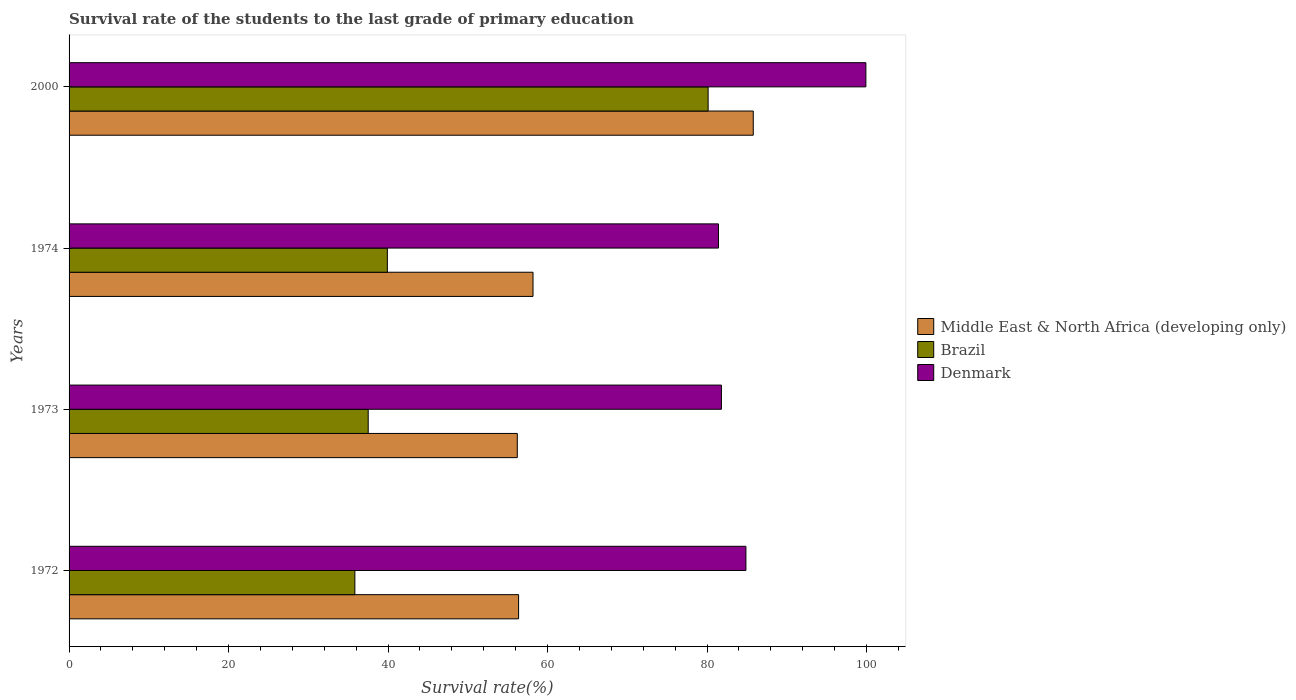How many different coloured bars are there?
Offer a very short reply. 3. How many bars are there on the 3rd tick from the top?
Keep it short and to the point. 3. How many bars are there on the 2nd tick from the bottom?
Your answer should be compact. 3. What is the label of the 1st group of bars from the top?
Offer a very short reply. 2000. What is the survival rate of the students in Brazil in 1972?
Give a very brief answer. 35.84. Across all years, what is the maximum survival rate of the students in Brazil?
Ensure brevity in your answer.  80.13. Across all years, what is the minimum survival rate of the students in Middle East & North Africa (developing only)?
Provide a succinct answer. 56.2. In which year was the survival rate of the students in Middle East & North Africa (developing only) maximum?
Give a very brief answer. 2000. In which year was the survival rate of the students in Denmark minimum?
Your response must be concise. 1974. What is the total survival rate of the students in Brazil in the graph?
Offer a very short reply. 193.39. What is the difference between the survival rate of the students in Denmark in 1973 and that in 2000?
Offer a terse response. -18.11. What is the difference between the survival rate of the students in Brazil in 1973 and the survival rate of the students in Middle East & North Africa (developing only) in 1974?
Keep it short and to the point. -20.67. What is the average survival rate of the students in Denmark per year?
Provide a short and direct response. 87. In the year 1973, what is the difference between the survival rate of the students in Brazil and survival rate of the students in Middle East & North Africa (developing only)?
Make the answer very short. -18.7. In how many years, is the survival rate of the students in Middle East & North Africa (developing only) greater than 88 %?
Your answer should be very brief. 0. What is the ratio of the survival rate of the students in Middle East & North Africa (developing only) in 1972 to that in 1973?
Ensure brevity in your answer.  1. What is the difference between the highest and the second highest survival rate of the students in Denmark?
Your answer should be compact. 15.04. What is the difference between the highest and the lowest survival rate of the students in Middle East & North Africa (developing only)?
Your answer should be compact. 29.59. Is the sum of the survival rate of the students in Denmark in 1972 and 1973 greater than the maximum survival rate of the students in Middle East & North Africa (developing only) across all years?
Your answer should be compact. Yes. What does the 3rd bar from the top in 1973 represents?
Your answer should be compact. Middle East & North Africa (developing only). What does the 1st bar from the bottom in 1974 represents?
Provide a succinct answer. Middle East & North Africa (developing only). Is it the case that in every year, the sum of the survival rate of the students in Denmark and survival rate of the students in Middle East & North Africa (developing only) is greater than the survival rate of the students in Brazil?
Keep it short and to the point. Yes. What is the difference between two consecutive major ticks on the X-axis?
Offer a very short reply. 20. Does the graph contain any zero values?
Give a very brief answer. No. How many legend labels are there?
Your answer should be compact. 3. What is the title of the graph?
Make the answer very short. Survival rate of the students to the last grade of primary education. Does "French Polynesia" appear as one of the legend labels in the graph?
Make the answer very short. No. What is the label or title of the X-axis?
Your response must be concise. Survival rate(%). What is the Survival rate(%) in Middle East & North Africa (developing only) in 1972?
Your answer should be very brief. 56.37. What is the Survival rate(%) in Brazil in 1972?
Ensure brevity in your answer.  35.84. What is the Survival rate(%) of Denmark in 1972?
Provide a short and direct response. 84.87. What is the Survival rate(%) in Middle East & North Africa (developing only) in 1973?
Keep it short and to the point. 56.2. What is the Survival rate(%) of Brazil in 1973?
Provide a succinct answer. 37.51. What is the Survival rate(%) in Denmark in 1973?
Offer a terse response. 81.8. What is the Survival rate(%) in Middle East & North Africa (developing only) in 1974?
Your answer should be very brief. 58.18. What is the Survival rate(%) in Brazil in 1974?
Your response must be concise. 39.91. What is the Survival rate(%) of Denmark in 1974?
Offer a terse response. 81.43. What is the Survival rate(%) in Middle East & North Africa (developing only) in 2000?
Provide a succinct answer. 85.79. What is the Survival rate(%) in Brazil in 2000?
Offer a terse response. 80.13. What is the Survival rate(%) in Denmark in 2000?
Give a very brief answer. 99.91. Across all years, what is the maximum Survival rate(%) of Middle East & North Africa (developing only)?
Your answer should be compact. 85.79. Across all years, what is the maximum Survival rate(%) of Brazil?
Your response must be concise. 80.13. Across all years, what is the maximum Survival rate(%) in Denmark?
Provide a short and direct response. 99.91. Across all years, what is the minimum Survival rate(%) in Middle East & North Africa (developing only)?
Keep it short and to the point. 56.2. Across all years, what is the minimum Survival rate(%) of Brazil?
Keep it short and to the point. 35.84. Across all years, what is the minimum Survival rate(%) of Denmark?
Ensure brevity in your answer.  81.43. What is the total Survival rate(%) in Middle East & North Africa (developing only) in the graph?
Offer a terse response. 256.54. What is the total Survival rate(%) of Brazil in the graph?
Your response must be concise. 193.39. What is the total Survival rate(%) of Denmark in the graph?
Make the answer very short. 348.01. What is the difference between the Survival rate(%) in Middle East & North Africa (developing only) in 1972 and that in 1973?
Keep it short and to the point. 0.16. What is the difference between the Survival rate(%) of Brazil in 1972 and that in 1973?
Give a very brief answer. -1.67. What is the difference between the Survival rate(%) of Denmark in 1972 and that in 1973?
Offer a very short reply. 3.07. What is the difference between the Survival rate(%) in Middle East & North Africa (developing only) in 1972 and that in 1974?
Give a very brief answer. -1.81. What is the difference between the Survival rate(%) in Brazil in 1972 and that in 1974?
Offer a terse response. -4.07. What is the difference between the Survival rate(%) in Denmark in 1972 and that in 1974?
Keep it short and to the point. 3.44. What is the difference between the Survival rate(%) of Middle East & North Africa (developing only) in 1972 and that in 2000?
Provide a short and direct response. -29.43. What is the difference between the Survival rate(%) of Brazil in 1972 and that in 2000?
Make the answer very short. -44.3. What is the difference between the Survival rate(%) in Denmark in 1972 and that in 2000?
Offer a terse response. -15.04. What is the difference between the Survival rate(%) of Middle East & North Africa (developing only) in 1973 and that in 1974?
Your answer should be compact. -1.97. What is the difference between the Survival rate(%) in Brazil in 1973 and that in 1974?
Make the answer very short. -2.4. What is the difference between the Survival rate(%) in Denmark in 1973 and that in 1974?
Your response must be concise. 0.37. What is the difference between the Survival rate(%) in Middle East & North Africa (developing only) in 1973 and that in 2000?
Give a very brief answer. -29.59. What is the difference between the Survival rate(%) of Brazil in 1973 and that in 2000?
Keep it short and to the point. -42.62. What is the difference between the Survival rate(%) of Denmark in 1973 and that in 2000?
Provide a succinct answer. -18.11. What is the difference between the Survival rate(%) of Middle East & North Africa (developing only) in 1974 and that in 2000?
Offer a terse response. -27.62. What is the difference between the Survival rate(%) of Brazil in 1974 and that in 2000?
Your response must be concise. -40.22. What is the difference between the Survival rate(%) of Denmark in 1974 and that in 2000?
Your answer should be very brief. -18.48. What is the difference between the Survival rate(%) of Middle East & North Africa (developing only) in 1972 and the Survival rate(%) of Brazil in 1973?
Your answer should be very brief. 18.86. What is the difference between the Survival rate(%) in Middle East & North Africa (developing only) in 1972 and the Survival rate(%) in Denmark in 1973?
Provide a short and direct response. -25.43. What is the difference between the Survival rate(%) of Brazil in 1972 and the Survival rate(%) of Denmark in 1973?
Provide a succinct answer. -45.96. What is the difference between the Survival rate(%) of Middle East & North Africa (developing only) in 1972 and the Survival rate(%) of Brazil in 1974?
Ensure brevity in your answer.  16.45. What is the difference between the Survival rate(%) in Middle East & North Africa (developing only) in 1972 and the Survival rate(%) in Denmark in 1974?
Your answer should be compact. -25.06. What is the difference between the Survival rate(%) in Brazil in 1972 and the Survival rate(%) in Denmark in 1974?
Your answer should be very brief. -45.59. What is the difference between the Survival rate(%) of Middle East & North Africa (developing only) in 1972 and the Survival rate(%) of Brazil in 2000?
Give a very brief answer. -23.77. What is the difference between the Survival rate(%) in Middle East & North Africa (developing only) in 1972 and the Survival rate(%) in Denmark in 2000?
Offer a very short reply. -43.55. What is the difference between the Survival rate(%) of Brazil in 1972 and the Survival rate(%) of Denmark in 2000?
Give a very brief answer. -64.08. What is the difference between the Survival rate(%) of Middle East & North Africa (developing only) in 1973 and the Survival rate(%) of Brazil in 1974?
Make the answer very short. 16.29. What is the difference between the Survival rate(%) of Middle East & North Africa (developing only) in 1973 and the Survival rate(%) of Denmark in 1974?
Your response must be concise. -25.23. What is the difference between the Survival rate(%) of Brazil in 1973 and the Survival rate(%) of Denmark in 1974?
Give a very brief answer. -43.92. What is the difference between the Survival rate(%) in Middle East & North Africa (developing only) in 1973 and the Survival rate(%) in Brazil in 2000?
Provide a short and direct response. -23.93. What is the difference between the Survival rate(%) of Middle East & North Africa (developing only) in 1973 and the Survival rate(%) of Denmark in 2000?
Provide a succinct answer. -43.71. What is the difference between the Survival rate(%) of Brazil in 1973 and the Survival rate(%) of Denmark in 2000?
Make the answer very short. -62.4. What is the difference between the Survival rate(%) in Middle East & North Africa (developing only) in 1974 and the Survival rate(%) in Brazil in 2000?
Provide a short and direct response. -21.96. What is the difference between the Survival rate(%) of Middle East & North Africa (developing only) in 1974 and the Survival rate(%) of Denmark in 2000?
Your answer should be compact. -41.74. What is the difference between the Survival rate(%) of Brazil in 1974 and the Survival rate(%) of Denmark in 2000?
Give a very brief answer. -60. What is the average Survival rate(%) in Middle East & North Africa (developing only) per year?
Provide a succinct answer. 64.13. What is the average Survival rate(%) of Brazil per year?
Offer a terse response. 48.35. What is the average Survival rate(%) of Denmark per year?
Offer a terse response. 87. In the year 1972, what is the difference between the Survival rate(%) of Middle East & North Africa (developing only) and Survival rate(%) of Brazil?
Your response must be concise. 20.53. In the year 1972, what is the difference between the Survival rate(%) of Middle East & North Africa (developing only) and Survival rate(%) of Denmark?
Provide a short and direct response. -28.51. In the year 1972, what is the difference between the Survival rate(%) of Brazil and Survival rate(%) of Denmark?
Your answer should be very brief. -49.04. In the year 1973, what is the difference between the Survival rate(%) in Middle East & North Africa (developing only) and Survival rate(%) in Brazil?
Provide a short and direct response. 18.7. In the year 1973, what is the difference between the Survival rate(%) of Middle East & North Africa (developing only) and Survival rate(%) of Denmark?
Your answer should be compact. -25.6. In the year 1973, what is the difference between the Survival rate(%) of Brazil and Survival rate(%) of Denmark?
Your response must be concise. -44.29. In the year 1974, what is the difference between the Survival rate(%) of Middle East & North Africa (developing only) and Survival rate(%) of Brazil?
Offer a terse response. 18.26. In the year 1974, what is the difference between the Survival rate(%) of Middle East & North Africa (developing only) and Survival rate(%) of Denmark?
Keep it short and to the point. -23.25. In the year 1974, what is the difference between the Survival rate(%) of Brazil and Survival rate(%) of Denmark?
Provide a succinct answer. -41.52. In the year 2000, what is the difference between the Survival rate(%) of Middle East & North Africa (developing only) and Survival rate(%) of Brazil?
Give a very brief answer. 5.66. In the year 2000, what is the difference between the Survival rate(%) in Middle East & North Africa (developing only) and Survival rate(%) in Denmark?
Give a very brief answer. -14.12. In the year 2000, what is the difference between the Survival rate(%) in Brazil and Survival rate(%) in Denmark?
Offer a terse response. -19.78. What is the ratio of the Survival rate(%) of Brazil in 1972 to that in 1973?
Ensure brevity in your answer.  0.96. What is the ratio of the Survival rate(%) in Denmark in 1972 to that in 1973?
Offer a terse response. 1.04. What is the ratio of the Survival rate(%) of Middle East & North Africa (developing only) in 1972 to that in 1974?
Your answer should be very brief. 0.97. What is the ratio of the Survival rate(%) in Brazil in 1972 to that in 1974?
Provide a succinct answer. 0.9. What is the ratio of the Survival rate(%) of Denmark in 1972 to that in 1974?
Provide a succinct answer. 1.04. What is the ratio of the Survival rate(%) of Middle East & North Africa (developing only) in 1972 to that in 2000?
Keep it short and to the point. 0.66. What is the ratio of the Survival rate(%) in Brazil in 1972 to that in 2000?
Your answer should be compact. 0.45. What is the ratio of the Survival rate(%) of Denmark in 1972 to that in 2000?
Your response must be concise. 0.85. What is the ratio of the Survival rate(%) of Middle East & North Africa (developing only) in 1973 to that in 1974?
Provide a short and direct response. 0.97. What is the ratio of the Survival rate(%) in Brazil in 1973 to that in 1974?
Your answer should be compact. 0.94. What is the ratio of the Survival rate(%) in Middle East & North Africa (developing only) in 1973 to that in 2000?
Ensure brevity in your answer.  0.66. What is the ratio of the Survival rate(%) in Brazil in 1973 to that in 2000?
Give a very brief answer. 0.47. What is the ratio of the Survival rate(%) in Denmark in 1973 to that in 2000?
Your answer should be compact. 0.82. What is the ratio of the Survival rate(%) in Middle East & North Africa (developing only) in 1974 to that in 2000?
Offer a terse response. 0.68. What is the ratio of the Survival rate(%) in Brazil in 1974 to that in 2000?
Your answer should be compact. 0.5. What is the ratio of the Survival rate(%) of Denmark in 1974 to that in 2000?
Offer a very short reply. 0.81. What is the difference between the highest and the second highest Survival rate(%) in Middle East & North Africa (developing only)?
Give a very brief answer. 27.62. What is the difference between the highest and the second highest Survival rate(%) of Brazil?
Your answer should be very brief. 40.22. What is the difference between the highest and the second highest Survival rate(%) in Denmark?
Give a very brief answer. 15.04. What is the difference between the highest and the lowest Survival rate(%) in Middle East & North Africa (developing only)?
Provide a succinct answer. 29.59. What is the difference between the highest and the lowest Survival rate(%) in Brazil?
Ensure brevity in your answer.  44.3. What is the difference between the highest and the lowest Survival rate(%) in Denmark?
Offer a terse response. 18.48. 